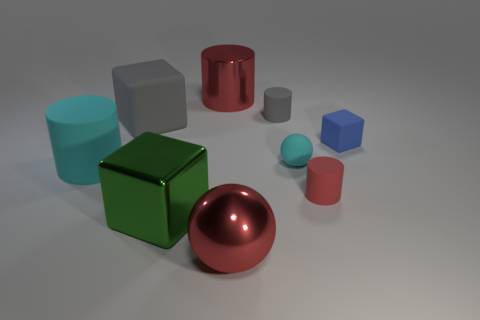Subtract all large gray blocks. How many blocks are left? 2 Subtract all cyan spheres. How many spheres are left? 1 Subtract all cylinders. How many objects are left? 5 Add 7 tiny blue blocks. How many tiny blue blocks exist? 8 Subtract 0 yellow cylinders. How many objects are left? 9 Subtract 1 cubes. How many cubes are left? 2 Subtract all gray cylinders. Subtract all brown spheres. How many cylinders are left? 3 Subtract all brown spheres. How many purple cylinders are left? 0 Subtract all large metal cylinders. Subtract all red things. How many objects are left? 5 Add 6 small red objects. How many small red objects are left? 7 